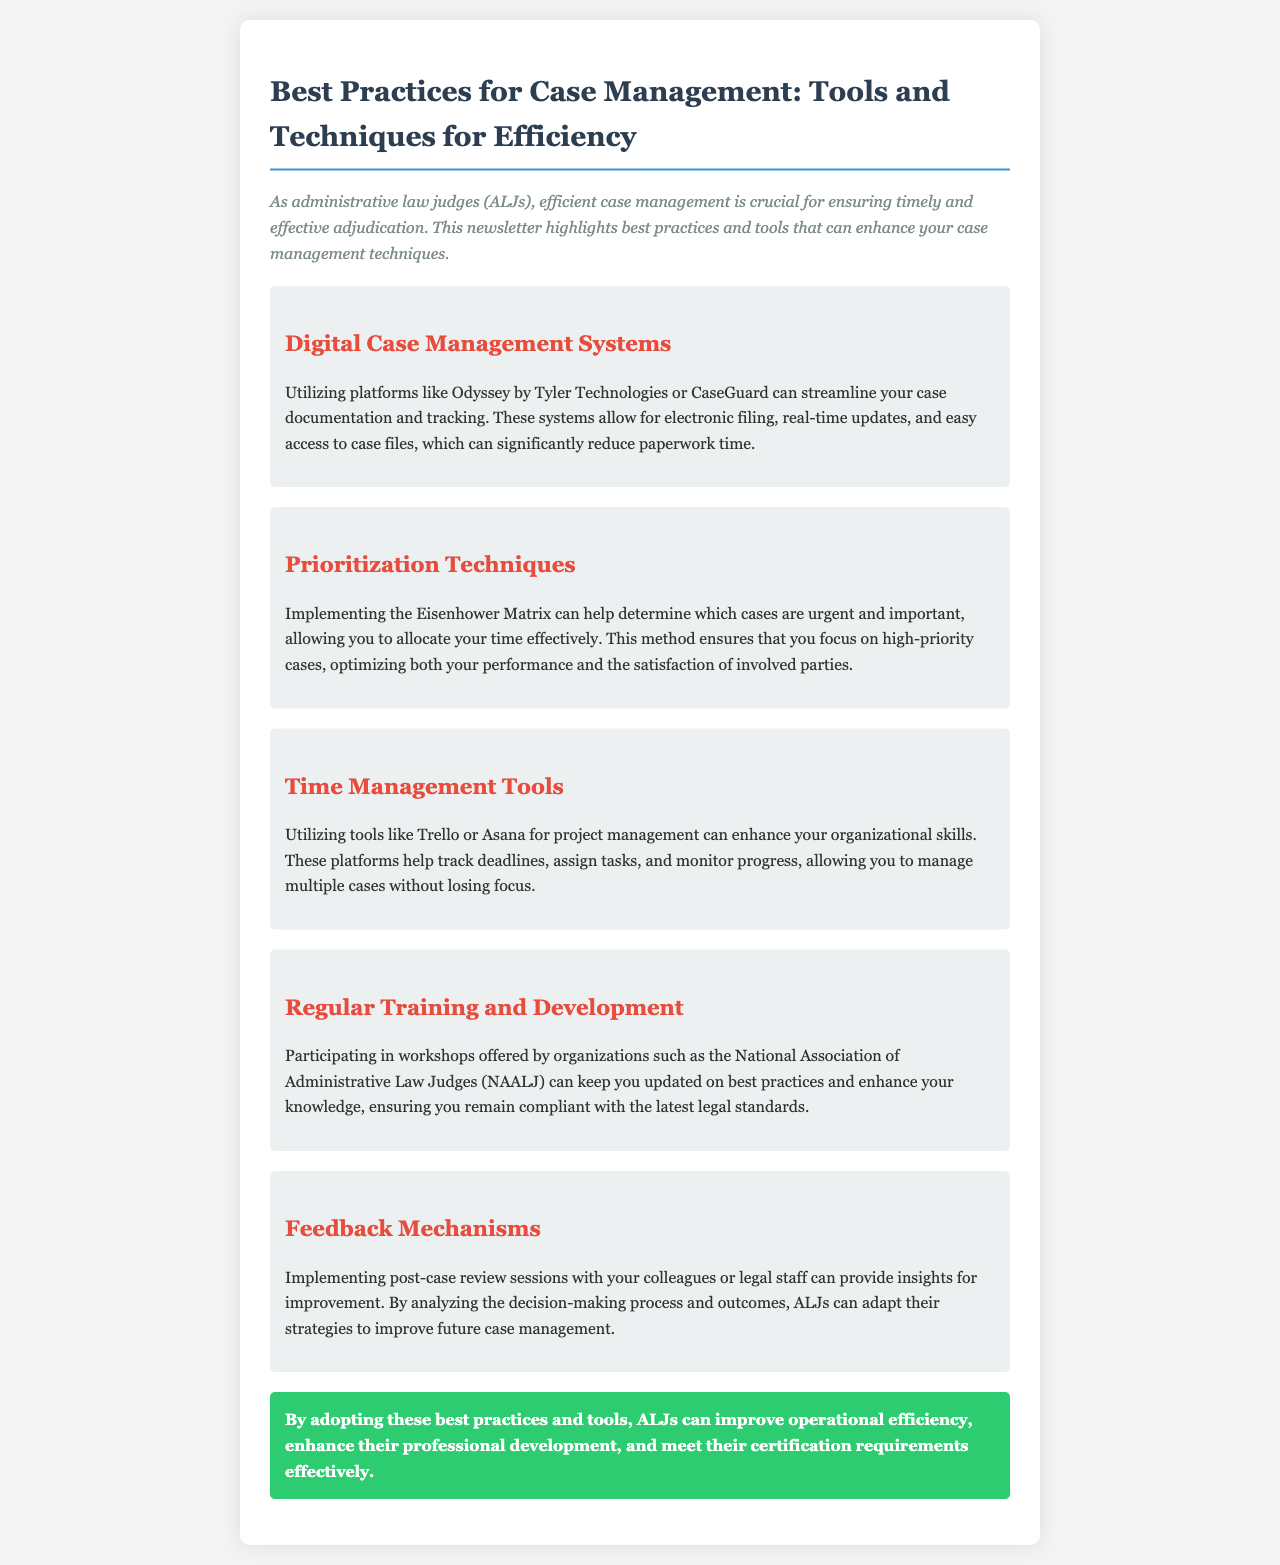What is the main focus of the newsletter? The newsletter emphasizes the importance of efficient case management for ALJs.
Answer: Efficient case management What digital case management systems are mentioned? The newsletter lists Odyssey by Tyler Technologies and CaseGuard as examples of digital case management systems.
Answer: Odyssey by Tyler Technologies or CaseGuard What prioritization technique is discussed? The document mentions the Eisenhower Matrix as a way to prioritize cases.
Answer: Eisenhower Matrix What time management tools are suggested? Trello and Asana are recommended for tracking deadlines and managing tasks.
Answer: Trello or Asana Which organization offers workshops for ALJs? The National Association of Administrative Law Judges (NAALJ) is mentioned as offering workshops.
Answer: National Association of Administrative Law Judges (NAALJ) What is the conclusion of the newsletter? The conclusion emphasizes the improvement in operational efficiency and professional development for ALJs.
Answer: Improve operational efficiency How does the document suggest gaining insights for improvement? It suggests implementing post-case review sessions with colleagues or legal staff.
Answer: Post-case review sessions What color indicates section headings in the document? The section headings are indicated in red color.
Answer: Red How many sections are included in the newsletter? There are five distinct sections in the newsletter besides the introduction and conclusion.
Answer: Five 